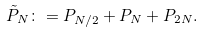Convert formula to latex. <formula><loc_0><loc_0><loc_500><loc_500>\tilde { P } _ { N } \colon = P _ { N / 2 } + P _ { N } + P _ { 2 N } .</formula> 